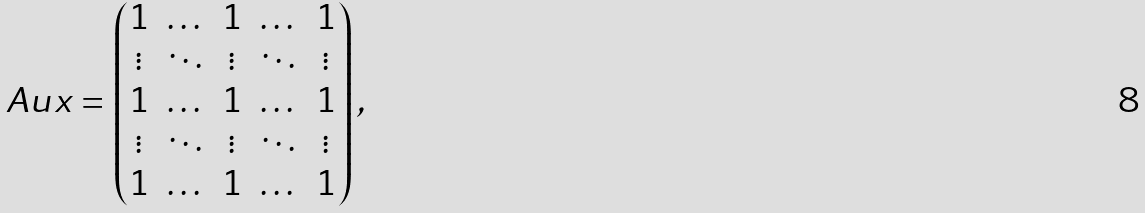<formula> <loc_0><loc_0><loc_500><loc_500>A u x = \begin{pmatrix} 1 & \dots & 1 & \dots & 1 \\ \vdots & \ddots & \vdots & \ddots & \vdots \\ 1 & \dots & 1 & \dots & 1 \\ \vdots & \ddots & \vdots & \ddots & \vdots \\ 1 & \dots & 1 & \dots & 1 \end{pmatrix} ,</formula> 